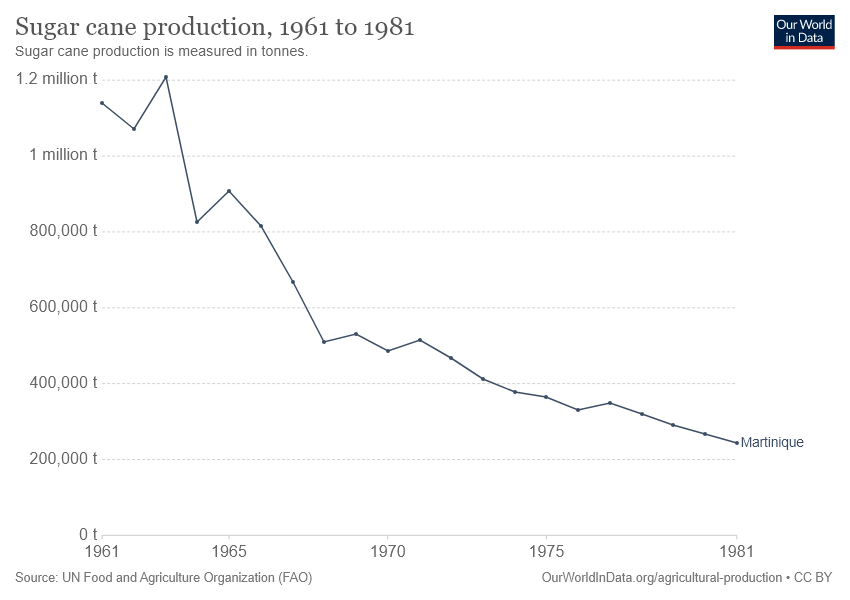Give some essential details in this illustration. The highest point in the graph occurred in the year 1963. The highest value of the peak in this border is 1.2.. 